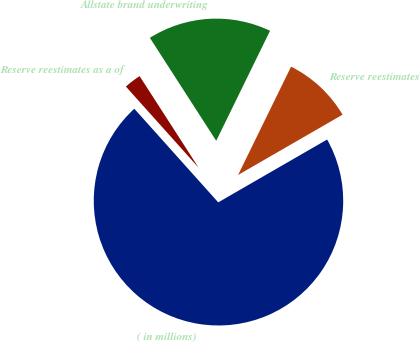Convert chart. <chart><loc_0><loc_0><loc_500><loc_500><pie_chart><fcel>( in millions)<fcel>Reserve reestimates<fcel>Allstate brand underwriting<fcel>Reserve reestimates as a of<nl><fcel>71.7%<fcel>9.43%<fcel>16.35%<fcel>2.52%<nl></chart> 